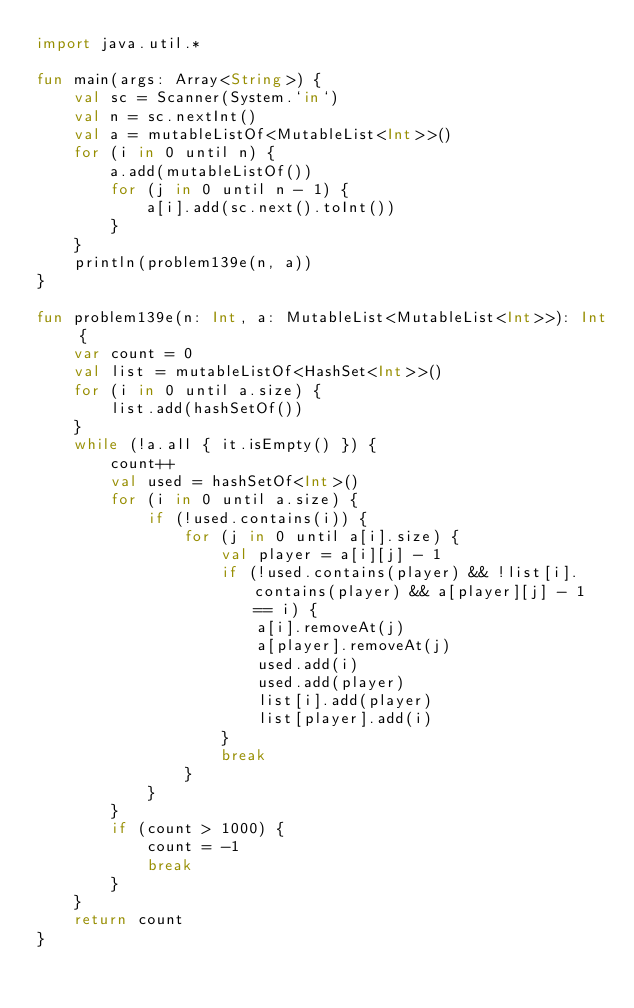<code> <loc_0><loc_0><loc_500><loc_500><_Kotlin_>import java.util.*

fun main(args: Array<String>) {
    val sc = Scanner(System.`in`)
    val n = sc.nextInt()
    val a = mutableListOf<MutableList<Int>>()
    for (i in 0 until n) {
        a.add(mutableListOf())
        for (j in 0 until n - 1) {
            a[i].add(sc.next().toInt())
        }
    }
    println(problem139e(n, a))
}

fun problem139e(n: Int, a: MutableList<MutableList<Int>>): Int {
    var count = 0
    val list = mutableListOf<HashSet<Int>>()
    for (i in 0 until a.size) {
        list.add(hashSetOf())
    }
    while (!a.all { it.isEmpty() }) {
        count++
        val used = hashSetOf<Int>()
        for (i in 0 until a.size) {
            if (!used.contains(i)) {
                for (j in 0 until a[i].size) {
                    val player = a[i][j] - 1
                    if (!used.contains(player) && !list[i].contains(player) && a[player][j] - 1 == i) {
                        a[i].removeAt(j)
                        a[player].removeAt(j)
                        used.add(i)
                        used.add(player)
                        list[i].add(player)
                        list[player].add(i)
                    }
                    break
                }
            }
        }
        if (count > 1000) {
            count = -1
            break
        }
    }
    return count
}</code> 